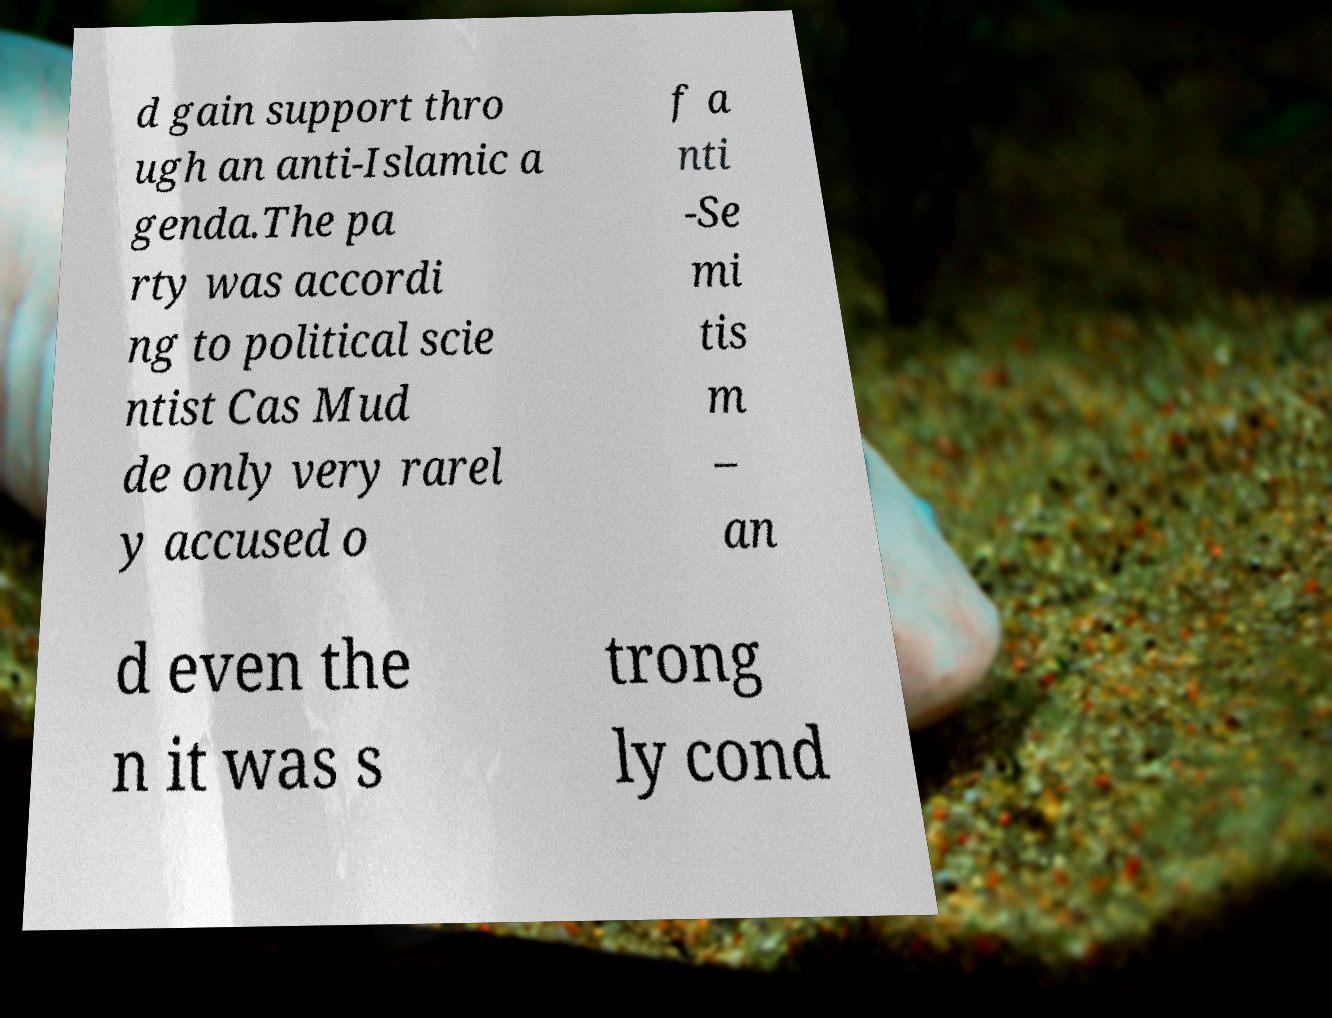Please read and relay the text visible in this image. What does it say? d gain support thro ugh an anti-Islamic a genda.The pa rty was accordi ng to political scie ntist Cas Mud de only very rarel y accused o f a nti -Se mi tis m – an d even the n it was s trong ly cond 